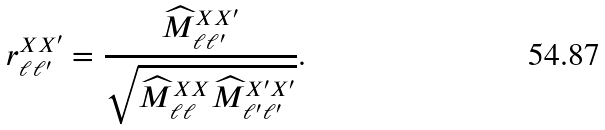Convert formula to latex. <formula><loc_0><loc_0><loc_500><loc_500>r ^ { X X ^ { \prime } } _ { \ell \ell ^ { \prime } } = \frac { \widehat { M } ^ { X X ^ { \prime } } _ { \ell \ell ^ { \prime } } } { \sqrt { \widehat { M } ^ { X X } _ { \ell \ell } \widehat { M } ^ { X ^ { \prime } X ^ { \prime } } _ { \ell ^ { \prime } \ell ^ { \prime } } } } .</formula> 